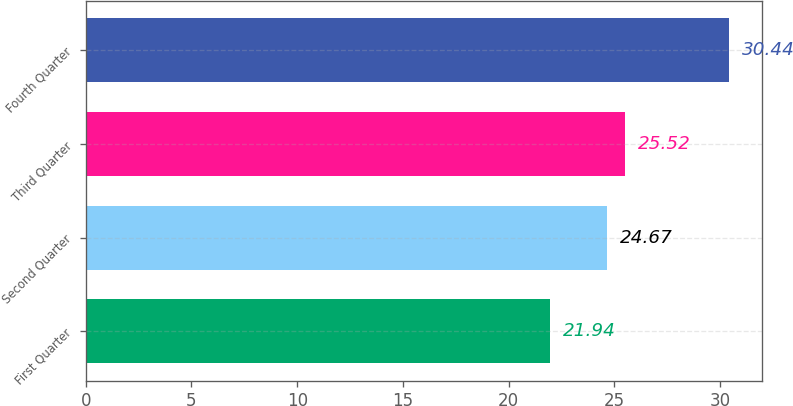Convert chart. <chart><loc_0><loc_0><loc_500><loc_500><bar_chart><fcel>First Quarter<fcel>Second Quarter<fcel>Third Quarter<fcel>Fourth Quarter<nl><fcel>21.94<fcel>24.67<fcel>25.52<fcel>30.44<nl></chart> 